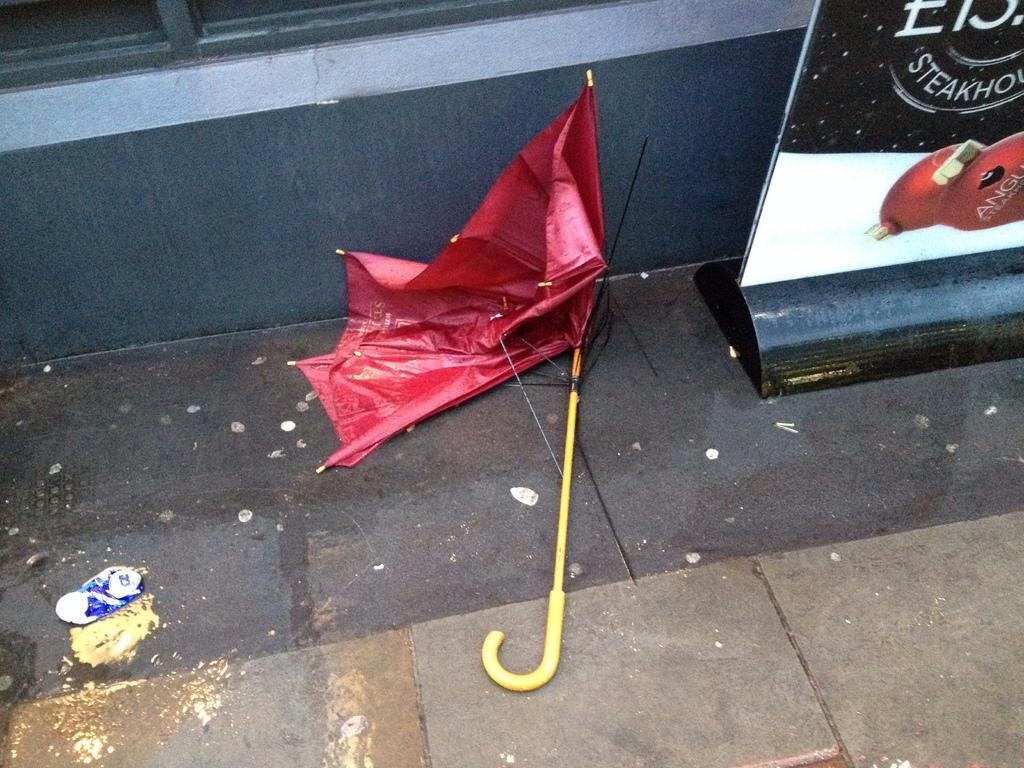What object is present in the image to provide shade or protection from the elements? There is an umbrella in the image. What can be found on the ground in the image? There is a board with text and an image on the ground. What can be seen in the distance in the image? There is a wall visible in the background of the image. What type of fuel is being used by the cook in the image? There is no cook or fuel present in the image. How many prisoners can be seen in the image? There are no prisoners or prison in the image. 